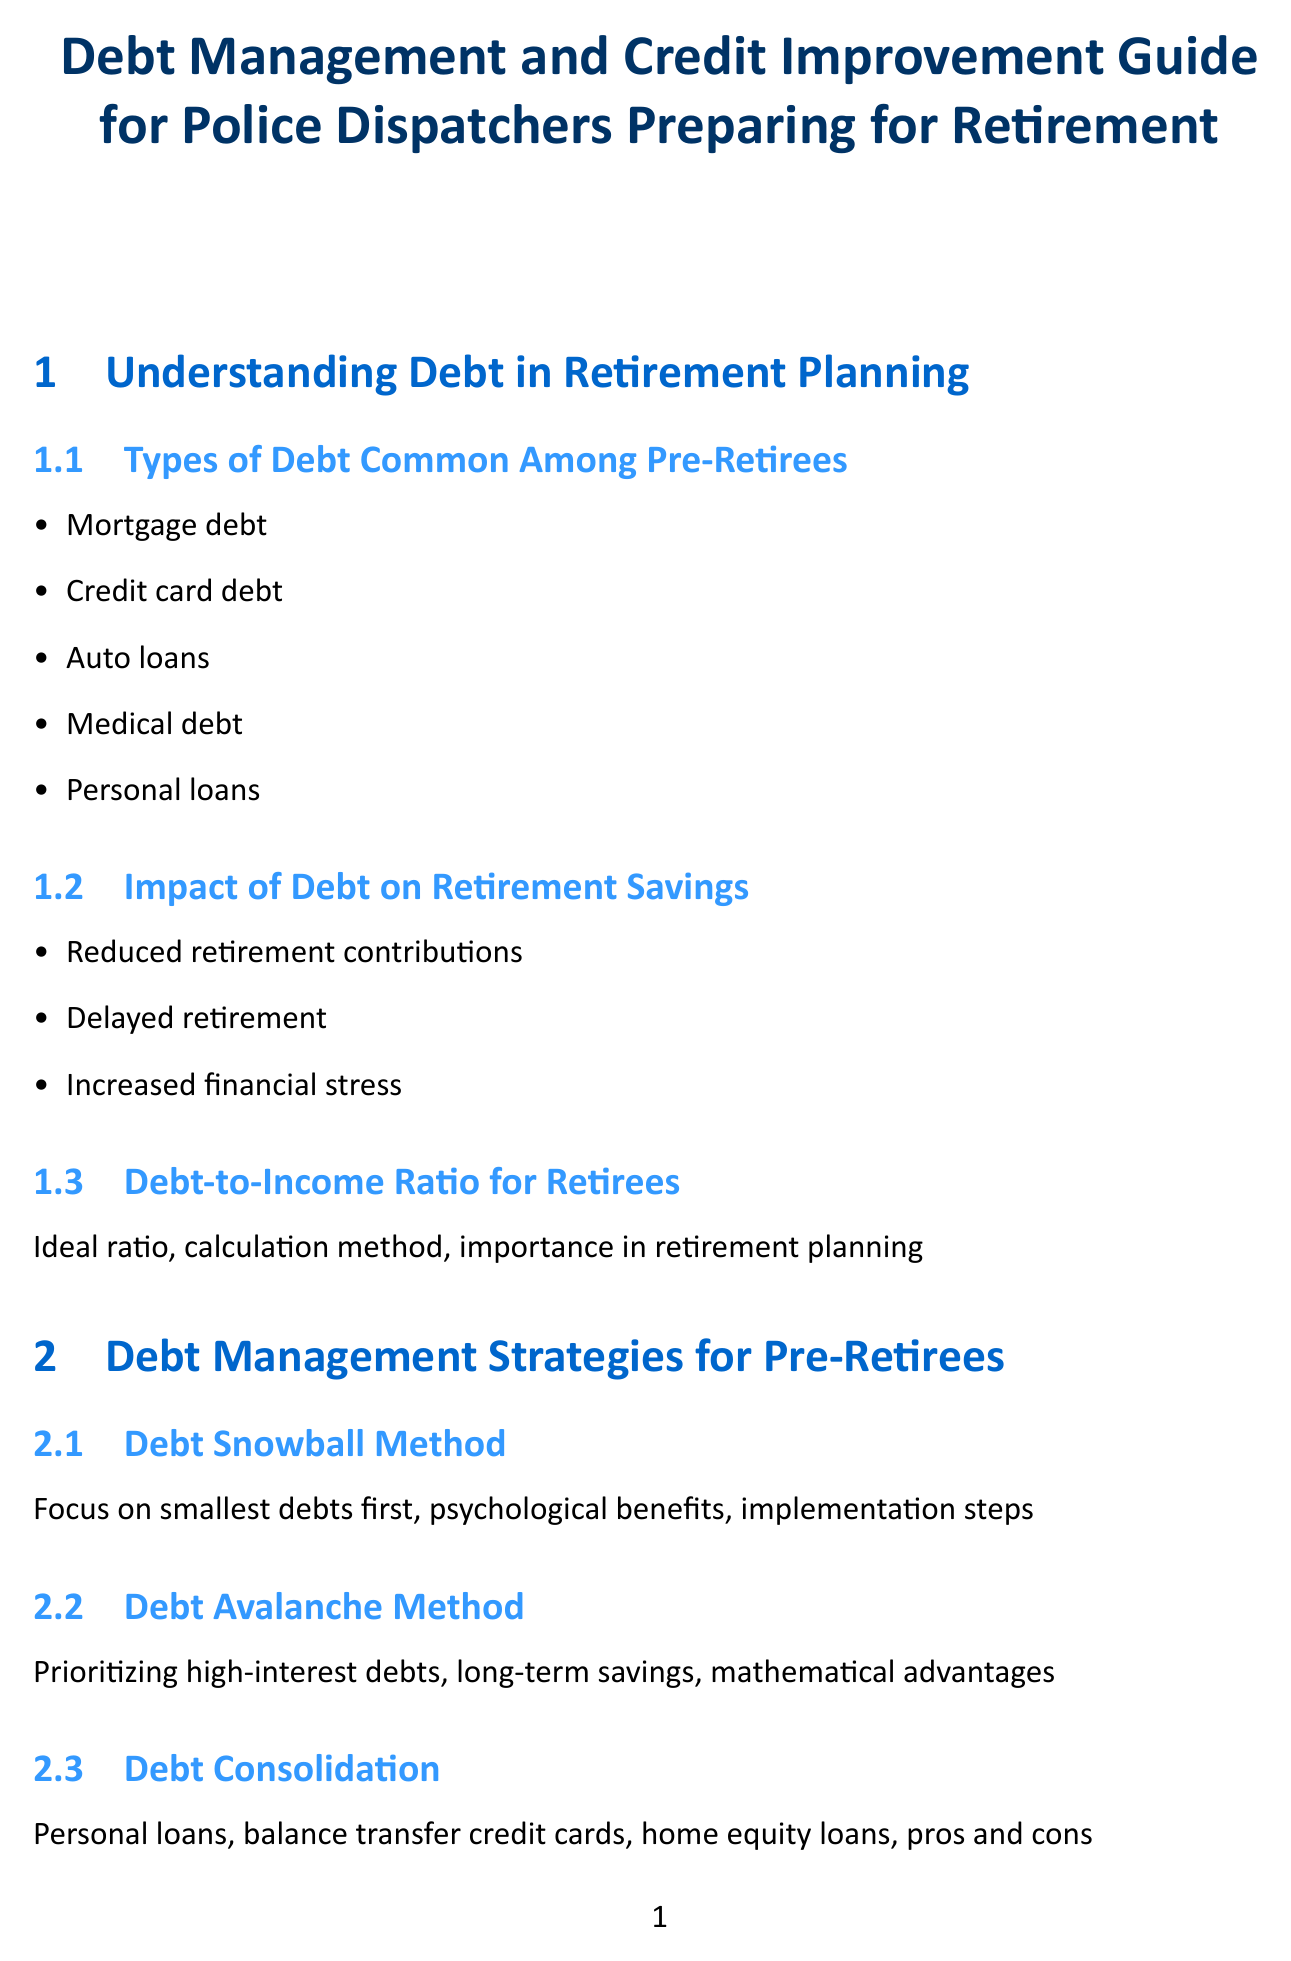What are common types of debt among pre-retirees? The section lists mortgage debt, credit card debt, auto loans, medical debt, and personal loans as common types of debt.
Answer: Mortgage debt, credit card debt, auto loans, medical debt, personal loans What does the debt snowball method focus on? This method emphasizes paying off the smallest debts first for psychological benefits.
Answer: Smallest debts first What is the ideal credit utilization ratio? The document describes the ideal credit utilization ratio but does not provide a specific number; it mentions reducing credit utilization is important.
Answer: Ideal ratio What should be included in a pre-retirement budget? The budget should involve tracking expenses, identifying areas for cost-cutting, and allocating funds for debt repayment.
Answer: Tracking expenses, cost-cutting, debt repayment What is a benefit of using additional income for debt repayment? Strategically using additional income helps in reducing overall debt quickly and effectively.
Answer: Reducing overall debt What program helps police dispatchers with debt management? The manual references employee assistance programs that offer financial counseling services for debt management.
Answer: Employee Assistance Programs What are the two types of bankruptcy mentioned? The manual outlines Chapter 7 and Chapter 13 bankruptcy as options for debt relief.
Answer: Chapter 7, Chapter 13 What financial considerations should be made for retirees regarding healthcare? Planning for healthcare costs includes Health Savings Accounts (HSAs), long-term care insurance, and Medicare planning.
Answer: HSAs, long-term care insurance, Medicare planning 